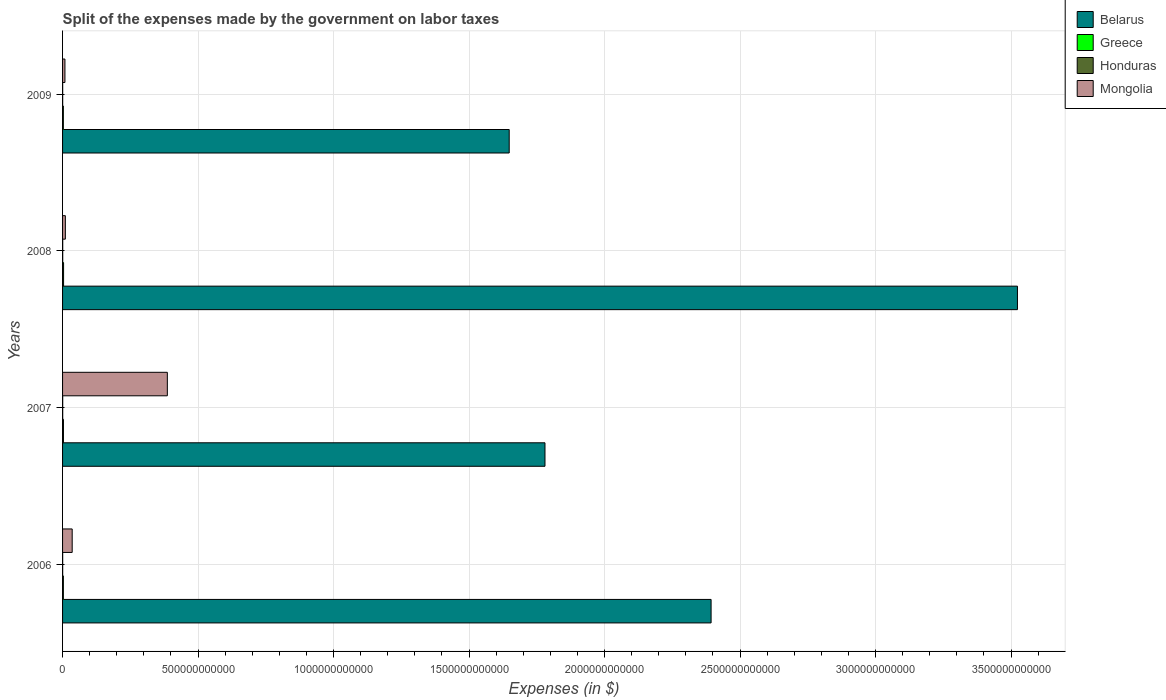Are the number of bars per tick equal to the number of legend labels?
Give a very brief answer. Yes. How many bars are there on the 2nd tick from the bottom?
Make the answer very short. 4. What is the expenses made by the government on labor taxes in Mongolia in 2009?
Ensure brevity in your answer.  8.78e+09. Across all years, what is the maximum expenses made by the government on labor taxes in Honduras?
Make the answer very short. 5.44e+08. Across all years, what is the minimum expenses made by the government on labor taxes in Belarus?
Give a very brief answer. 1.65e+12. What is the total expenses made by the government on labor taxes in Mongolia in the graph?
Provide a short and direct response. 4.41e+11. What is the difference between the expenses made by the government on labor taxes in Mongolia in 2006 and that in 2007?
Keep it short and to the point. -3.51e+11. What is the difference between the expenses made by the government on labor taxes in Greece in 2006 and the expenses made by the government on labor taxes in Mongolia in 2009?
Offer a terse response. -5.77e+09. What is the average expenses made by the government on labor taxes in Honduras per year?
Make the answer very short. 4.49e+08. In the year 2009, what is the difference between the expenses made by the government on labor taxes in Mongolia and expenses made by the government on labor taxes in Honduras?
Offer a very short reply. 8.39e+09. In how many years, is the expenses made by the government on labor taxes in Honduras greater than 3400000000000 $?
Provide a succinct answer. 0. What is the ratio of the expenses made by the government on labor taxes in Greece in 2007 to that in 2008?
Offer a very short reply. 0.89. Is the expenses made by the government on labor taxes in Belarus in 2008 less than that in 2009?
Make the answer very short. No. Is the difference between the expenses made by the government on labor taxes in Mongolia in 2007 and 2008 greater than the difference between the expenses made by the government on labor taxes in Honduras in 2007 and 2008?
Offer a terse response. Yes. What is the difference between the highest and the second highest expenses made by the government on labor taxes in Belarus?
Your answer should be compact. 1.13e+12. What is the difference between the highest and the lowest expenses made by the government on labor taxes in Belarus?
Give a very brief answer. 1.88e+12. Is the sum of the expenses made by the government on labor taxes in Belarus in 2006 and 2008 greater than the maximum expenses made by the government on labor taxes in Mongolia across all years?
Give a very brief answer. Yes. Is it the case that in every year, the sum of the expenses made by the government on labor taxes in Greece and expenses made by the government on labor taxes in Belarus is greater than the sum of expenses made by the government on labor taxes in Mongolia and expenses made by the government on labor taxes in Honduras?
Give a very brief answer. Yes. What does the 4th bar from the top in 2006 represents?
Give a very brief answer. Belarus. What does the 3rd bar from the bottom in 2006 represents?
Offer a terse response. Honduras. How many bars are there?
Your response must be concise. 16. How many years are there in the graph?
Offer a terse response. 4. What is the difference between two consecutive major ticks on the X-axis?
Your answer should be very brief. 5.00e+11. Are the values on the major ticks of X-axis written in scientific E-notation?
Provide a short and direct response. No. Does the graph contain any zero values?
Your response must be concise. No. How many legend labels are there?
Make the answer very short. 4. How are the legend labels stacked?
Offer a terse response. Vertical. What is the title of the graph?
Your answer should be very brief. Split of the expenses made by the government on labor taxes. What is the label or title of the X-axis?
Ensure brevity in your answer.  Expenses (in $). What is the label or title of the Y-axis?
Keep it short and to the point. Years. What is the Expenses (in $) of Belarus in 2006?
Ensure brevity in your answer.  2.39e+12. What is the Expenses (in $) of Greece in 2006?
Keep it short and to the point. 3.01e+09. What is the Expenses (in $) of Honduras in 2006?
Your answer should be compact. 3.85e+08. What is the Expenses (in $) in Mongolia in 2006?
Make the answer very short. 3.55e+1. What is the Expenses (in $) of Belarus in 2007?
Make the answer very short. 1.78e+12. What is the Expenses (in $) in Greece in 2007?
Offer a terse response. 3.29e+09. What is the Expenses (in $) of Honduras in 2007?
Your response must be concise. 4.78e+08. What is the Expenses (in $) in Mongolia in 2007?
Provide a short and direct response. 3.87e+11. What is the Expenses (in $) in Belarus in 2008?
Provide a short and direct response. 3.52e+12. What is the Expenses (in $) in Greece in 2008?
Offer a terse response. 3.71e+09. What is the Expenses (in $) in Honduras in 2008?
Keep it short and to the point. 5.44e+08. What is the Expenses (in $) of Mongolia in 2008?
Your response must be concise. 1.03e+1. What is the Expenses (in $) in Belarus in 2009?
Keep it short and to the point. 1.65e+12. What is the Expenses (in $) in Greece in 2009?
Keep it short and to the point. 2.94e+09. What is the Expenses (in $) of Honduras in 2009?
Make the answer very short. 3.91e+08. What is the Expenses (in $) of Mongolia in 2009?
Your response must be concise. 8.78e+09. Across all years, what is the maximum Expenses (in $) in Belarus?
Provide a short and direct response. 3.52e+12. Across all years, what is the maximum Expenses (in $) in Greece?
Give a very brief answer. 3.71e+09. Across all years, what is the maximum Expenses (in $) of Honduras?
Make the answer very short. 5.44e+08. Across all years, what is the maximum Expenses (in $) of Mongolia?
Provide a succinct answer. 3.87e+11. Across all years, what is the minimum Expenses (in $) of Belarus?
Ensure brevity in your answer.  1.65e+12. Across all years, what is the minimum Expenses (in $) in Greece?
Your answer should be very brief. 2.94e+09. Across all years, what is the minimum Expenses (in $) of Honduras?
Provide a succinct answer. 3.85e+08. Across all years, what is the minimum Expenses (in $) in Mongolia?
Provide a short and direct response. 8.78e+09. What is the total Expenses (in $) of Belarus in the graph?
Offer a very short reply. 9.35e+12. What is the total Expenses (in $) in Greece in the graph?
Ensure brevity in your answer.  1.30e+1. What is the total Expenses (in $) in Honduras in the graph?
Make the answer very short. 1.80e+09. What is the total Expenses (in $) of Mongolia in the graph?
Offer a very short reply. 4.41e+11. What is the difference between the Expenses (in $) in Belarus in 2006 and that in 2007?
Your answer should be very brief. 6.13e+11. What is the difference between the Expenses (in $) in Greece in 2006 and that in 2007?
Keep it short and to the point. -2.81e+08. What is the difference between the Expenses (in $) in Honduras in 2006 and that in 2007?
Keep it short and to the point. -9.28e+07. What is the difference between the Expenses (in $) of Mongolia in 2006 and that in 2007?
Ensure brevity in your answer.  -3.51e+11. What is the difference between the Expenses (in $) of Belarus in 2006 and that in 2008?
Provide a short and direct response. -1.13e+12. What is the difference between the Expenses (in $) of Greece in 2006 and that in 2008?
Your answer should be compact. -6.94e+08. What is the difference between the Expenses (in $) of Honduras in 2006 and that in 2008?
Keep it short and to the point. -1.59e+08. What is the difference between the Expenses (in $) of Mongolia in 2006 and that in 2008?
Offer a very short reply. 2.52e+1. What is the difference between the Expenses (in $) in Belarus in 2006 and that in 2009?
Your answer should be compact. 7.45e+11. What is the difference between the Expenses (in $) in Greece in 2006 and that in 2009?
Offer a very short reply. 7.60e+07. What is the difference between the Expenses (in $) in Honduras in 2006 and that in 2009?
Keep it short and to the point. -5.80e+06. What is the difference between the Expenses (in $) in Mongolia in 2006 and that in 2009?
Provide a short and direct response. 2.67e+1. What is the difference between the Expenses (in $) in Belarus in 2007 and that in 2008?
Provide a short and direct response. -1.74e+12. What is the difference between the Expenses (in $) in Greece in 2007 and that in 2008?
Offer a very short reply. -4.13e+08. What is the difference between the Expenses (in $) of Honduras in 2007 and that in 2008?
Your answer should be very brief. -6.61e+07. What is the difference between the Expenses (in $) in Mongolia in 2007 and that in 2008?
Your response must be concise. 3.76e+11. What is the difference between the Expenses (in $) of Belarus in 2007 and that in 2009?
Your response must be concise. 1.32e+11. What is the difference between the Expenses (in $) in Greece in 2007 and that in 2009?
Offer a terse response. 3.57e+08. What is the difference between the Expenses (in $) in Honduras in 2007 and that in 2009?
Your response must be concise. 8.70e+07. What is the difference between the Expenses (in $) in Mongolia in 2007 and that in 2009?
Keep it short and to the point. 3.78e+11. What is the difference between the Expenses (in $) in Belarus in 2008 and that in 2009?
Your response must be concise. 1.88e+12. What is the difference between the Expenses (in $) of Greece in 2008 and that in 2009?
Ensure brevity in your answer.  7.70e+08. What is the difference between the Expenses (in $) of Honduras in 2008 and that in 2009?
Offer a very short reply. 1.53e+08. What is the difference between the Expenses (in $) in Mongolia in 2008 and that in 2009?
Provide a succinct answer. 1.55e+09. What is the difference between the Expenses (in $) in Belarus in 2006 and the Expenses (in $) in Greece in 2007?
Your response must be concise. 2.39e+12. What is the difference between the Expenses (in $) in Belarus in 2006 and the Expenses (in $) in Honduras in 2007?
Make the answer very short. 2.39e+12. What is the difference between the Expenses (in $) in Belarus in 2006 and the Expenses (in $) in Mongolia in 2007?
Keep it short and to the point. 2.01e+12. What is the difference between the Expenses (in $) in Greece in 2006 and the Expenses (in $) in Honduras in 2007?
Offer a terse response. 2.54e+09. What is the difference between the Expenses (in $) of Greece in 2006 and the Expenses (in $) of Mongolia in 2007?
Your answer should be very brief. -3.84e+11. What is the difference between the Expenses (in $) of Honduras in 2006 and the Expenses (in $) of Mongolia in 2007?
Your answer should be compact. -3.86e+11. What is the difference between the Expenses (in $) in Belarus in 2006 and the Expenses (in $) in Greece in 2008?
Your response must be concise. 2.39e+12. What is the difference between the Expenses (in $) in Belarus in 2006 and the Expenses (in $) in Honduras in 2008?
Ensure brevity in your answer.  2.39e+12. What is the difference between the Expenses (in $) in Belarus in 2006 and the Expenses (in $) in Mongolia in 2008?
Your response must be concise. 2.38e+12. What is the difference between the Expenses (in $) in Greece in 2006 and the Expenses (in $) in Honduras in 2008?
Provide a short and direct response. 2.47e+09. What is the difference between the Expenses (in $) of Greece in 2006 and the Expenses (in $) of Mongolia in 2008?
Your answer should be compact. -7.32e+09. What is the difference between the Expenses (in $) in Honduras in 2006 and the Expenses (in $) in Mongolia in 2008?
Provide a short and direct response. -9.95e+09. What is the difference between the Expenses (in $) in Belarus in 2006 and the Expenses (in $) in Greece in 2009?
Ensure brevity in your answer.  2.39e+12. What is the difference between the Expenses (in $) in Belarus in 2006 and the Expenses (in $) in Honduras in 2009?
Offer a very short reply. 2.39e+12. What is the difference between the Expenses (in $) of Belarus in 2006 and the Expenses (in $) of Mongolia in 2009?
Give a very brief answer. 2.38e+12. What is the difference between the Expenses (in $) in Greece in 2006 and the Expenses (in $) in Honduras in 2009?
Provide a short and direct response. 2.62e+09. What is the difference between the Expenses (in $) of Greece in 2006 and the Expenses (in $) of Mongolia in 2009?
Keep it short and to the point. -5.77e+09. What is the difference between the Expenses (in $) of Honduras in 2006 and the Expenses (in $) of Mongolia in 2009?
Provide a short and direct response. -8.39e+09. What is the difference between the Expenses (in $) in Belarus in 2007 and the Expenses (in $) in Greece in 2008?
Your answer should be very brief. 1.78e+12. What is the difference between the Expenses (in $) in Belarus in 2007 and the Expenses (in $) in Honduras in 2008?
Your response must be concise. 1.78e+12. What is the difference between the Expenses (in $) of Belarus in 2007 and the Expenses (in $) of Mongolia in 2008?
Give a very brief answer. 1.77e+12. What is the difference between the Expenses (in $) in Greece in 2007 and the Expenses (in $) in Honduras in 2008?
Make the answer very short. 2.75e+09. What is the difference between the Expenses (in $) in Greece in 2007 and the Expenses (in $) in Mongolia in 2008?
Your answer should be very brief. -7.04e+09. What is the difference between the Expenses (in $) of Honduras in 2007 and the Expenses (in $) of Mongolia in 2008?
Provide a short and direct response. -9.85e+09. What is the difference between the Expenses (in $) in Belarus in 2007 and the Expenses (in $) in Greece in 2009?
Provide a short and direct response. 1.78e+12. What is the difference between the Expenses (in $) in Belarus in 2007 and the Expenses (in $) in Honduras in 2009?
Give a very brief answer. 1.78e+12. What is the difference between the Expenses (in $) in Belarus in 2007 and the Expenses (in $) in Mongolia in 2009?
Your answer should be very brief. 1.77e+12. What is the difference between the Expenses (in $) of Greece in 2007 and the Expenses (in $) of Honduras in 2009?
Your answer should be very brief. 2.90e+09. What is the difference between the Expenses (in $) in Greece in 2007 and the Expenses (in $) in Mongolia in 2009?
Ensure brevity in your answer.  -5.49e+09. What is the difference between the Expenses (in $) of Honduras in 2007 and the Expenses (in $) of Mongolia in 2009?
Your answer should be compact. -8.30e+09. What is the difference between the Expenses (in $) of Belarus in 2008 and the Expenses (in $) of Greece in 2009?
Your answer should be very brief. 3.52e+12. What is the difference between the Expenses (in $) in Belarus in 2008 and the Expenses (in $) in Honduras in 2009?
Provide a succinct answer. 3.52e+12. What is the difference between the Expenses (in $) in Belarus in 2008 and the Expenses (in $) in Mongolia in 2009?
Your response must be concise. 3.51e+12. What is the difference between the Expenses (in $) in Greece in 2008 and the Expenses (in $) in Honduras in 2009?
Keep it short and to the point. 3.32e+09. What is the difference between the Expenses (in $) in Greece in 2008 and the Expenses (in $) in Mongolia in 2009?
Your response must be concise. -5.07e+09. What is the difference between the Expenses (in $) of Honduras in 2008 and the Expenses (in $) of Mongolia in 2009?
Make the answer very short. -8.24e+09. What is the average Expenses (in $) in Belarus per year?
Keep it short and to the point. 2.34e+12. What is the average Expenses (in $) in Greece per year?
Give a very brief answer. 3.24e+09. What is the average Expenses (in $) in Honduras per year?
Make the answer very short. 4.49e+08. What is the average Expenses (in $) of Mongolia per year?
Your answer should be compact. 1.10e+11. In the year 2006, what is the difference between the Expenses (in $) of Belarus and Expenses (in $) of Greece?
Your answer should be very brief. 2.39e+12. In the year 2006, what is the difference between the Expenses (in $) in Belarus and Expenses (in $) in Honduras?
Provide a succinct answer. 2.39e+12. In the year 2006, what is the difference between the Expenses (in $) in Belarus and Expenses (in $) in Mongolia?
Offer a terse response. 2.36e+12. In the year 2006, what is the difference between the Expenses (in $) in Greece and Expenses (in $) in Honduras?
Your response must be concise. 2.63e+09. In the year 2006, what is the difference between the Expenses (in $) in Greece and Expenses (in $) in Mongolia?
Make the answer very short. -3.25e+1. In the year 2006, what is the difference between the Expenses (in $) of Honduras and Expenses (in $) of Mongolia?
Your answer should be very brief. -3.51e+1. In the year 2007, what is the difference between the Expenses (in $) of Belarus and Expenses (in $) of Greece?
Your response must be concise. 1.78e+12. In the year 2007, what is the difference between the Expenses (in $) in Belarus and Expenses (in $) in Honduras?
Your answer should be very brief. 1.78e+12. In the year 2007, what is the difference between the Expenses (in $) in Belarus and Expenses (in $) in Mongolia?
Offer a very short reply. 1.39e+12. In the year 2007, what is the difference between the Expenses (in $) of Greece and Expenses (in $) of Honduras?
Offer a very short reply. 2.82e+09. In the year 2007, what is the difference between the Expenses (in $) of Greece and Expenses (in $) of Mongolia?
Make the answer very short. -3.83e+11. In the year 2007, what is the difference between the Expenses (in $) in Honduras and Expenses (in $) in Mongolia?
Ensure brevity in your answer.  -3.86e+11. In the year 2008, what is the difference between the Expenses (in $) of Belarus and Expenses (in $) of Greece?
Ensure brevity in your answer.  3.52e+12. In the year 2008, what is the difference between the Expenses (in $) in Belarus and Expenses (in $) in Honduras?
Provide a succinct answer. 3.52e+12. In the year 2008, what is the difference between the Expenses (in $) in Belarus and Expenses (in $) in Mongolia?
Offer a terse response. 3.51e+12. In the year 2008, what is the difference between the Expenses (in $) of Greece and Expenses (in $) of Honduras?
Offer a very short reply. 3.16e+09. In the year 2008, what is the difference between the Expenses (in $) in Greece and Expenses (in $) in Mongolia?
Provide a short and direct response. -6.62e+09. In the year 2008, what is the difference between the Expenses (in $) of Honduras and Expenses (in $) of Mongolia?
Keep it short and to the point. -9.79e+09. In the year 2009, what is the difference between the Expenses (in $) in Belarus and Expenses (in $) in Greece?
Offer a very short reply. 1.65e+12. In the year 2009, what is the difference between the Expenses (in $) of Belarus and Expenses (in $) of Honduras?
Give a very brief answer. 1.65e+12. In the year 2009, what is the difference between the Expenses (in $) in Belarus and Expenses (in $) in Mongolia?
Your answer should be very brief. 1.64e+12. In the year 2009, what is the difference between the Expenses (in $) of Greece and Expenses (in $) of Honduras?
Ensure brevity in your answer.  2.55e+09. In the year 2009, what is the difference between the Expenses (in $) in Greece and Expenses (in $) in Mongolia?
Your answer should be compact. -5.84e+09. In the year 2009, what is the difference between the Expenses (in $) of Honduras and Expenses (in $) of Mongolia?
Offer a terse response. -8.39e+09. What is the ratio of the Expenses (in $) in Belarus in 2006 to that in 2007?
Your answer should be compact. 1.34. What is the ratio of the Expenses (in $) in Greece in 2006 to that in 2007?
Provide a succinct answer. 0.91. What is the ratio of the Expenses (in $) in Honduras in 2006 to that in 2007?
Provide a short and direct response. 0.81. What is the ratio of the Expenses (in $) of Mongolia in 2006 to that in 2007?
Ensure brevity in your answer.  0.09. What is the ratio of the Expenses (in $) of Belarus in 2006 to that in 2008?
Ensure brevity in your answer.  0.68. What is the ratio of the Expenses (in $) in Greece in 2006 to that in 2008?
Offer a very short reply. 0.81. What is the ratio of the Expenses (in $) in Honduras in 2006 to that in 2008?
Your answer should be compact. 0.71. What is the ratio of the Expenses (in $) of Mongolia in 2006 to that in 2008?
Your response must be concise. 3.44. What is the ratio of the Expenses (in $) in Belarus in 2006 to that in 2009?
Provide a succinct answer. 1.45. What is the ratio of the Expenses (in $) of Greece in 2006 to that in 2009?
Offer a very short reply. 1.03. What is the ratio of the Expenses (in $) in Honduras in 2006 to that in 2009?
Your answer should be compact. 0.99. What is the ratio of the Expenses (in $) of Mongolia in 2006 to that in 2009?
Your answer should be very brief. 4.05. What is the ratio of the Expenses (in $) in Belarus in 2007 to that in 2008?
Give a very brief answer. 0.51. What is the ratio of the Expenses (in $) of Greece in 2007 to that in 2008?
Offer a very short reply. 0.89. What is the ratio of the Expenses (in $) of Honduras in 2007 to that in 2008?
Provide a succinct answer. 0.88. What is the ratio of the Expenses (in $) of Mongolia in 2007 to that in 2008?
Offer a terse response. 37.43. What is the ratio of the Expenses (in $) of Belarus in 2007 to that in 2009?
Offer a terse response. 1.08. What is the ratio of the Expenses (in $) in Greece in 2007 to that in 2009?
Offer a very short reply. 1.12. What is the ratio of the Expenses (in $) in Honduras in 2007 to that in 2009?
Offer a very short reply. 1.22. What is the ratio of the Expenses (in $) in Mongolia in 2007 to that in 2009?
Make the answer very short. 44.04. What is the ratio of the Expenses (in $) in Belarus in 2008 to that in 2009?
Provide a short and direct response. 2.14. What is the ratio of the Expenses (in $) in Greece in 2008 to that in 2009?
Provide a short and direct response. 1.26. What is the ratio of the Expenses (in $) of Honduras in 2008 to that in 2009?
Offer a terse response. 1.39. What is the ratio of the Expenses (in $) in Mongolia in 2008 to that in 2009?
Provide a short and direct response. 1.18. What is the difference between the highest and the second highest Expenses (in $) of Belarus?
Make the answer very short. 1.13e+12. What is the difference between the highest and the second highest Expenses (in $) in Greece?
Ensure brevity in your answer.  4.13e+08. What is the difference between the highest and the second highest Expenses (in $) of Honduras?
Offer a very short reply. 6.61e+07. What is the difference between the highest and the second highest Expenses (in $) of Mongolia?
Your answer should be very brief. 3.51e+11. What is the difference between the highest and the lowest Expenses (in $) of Belarus?
Keep it short and to the point. 1.88e+12. What is the difference between the highest and the lowest Expenses (in $) in Greece?
Give a very brief answer. 7.70e+08. What is the difference between the highest and the lowest Expenses (in $) in Honduras?
Give a very brief answer. 1.59e+08. What is the difference between the highest and the lowest Expenses (in $) in Mongolia?
Offer a terse response. 3.78e+11. 